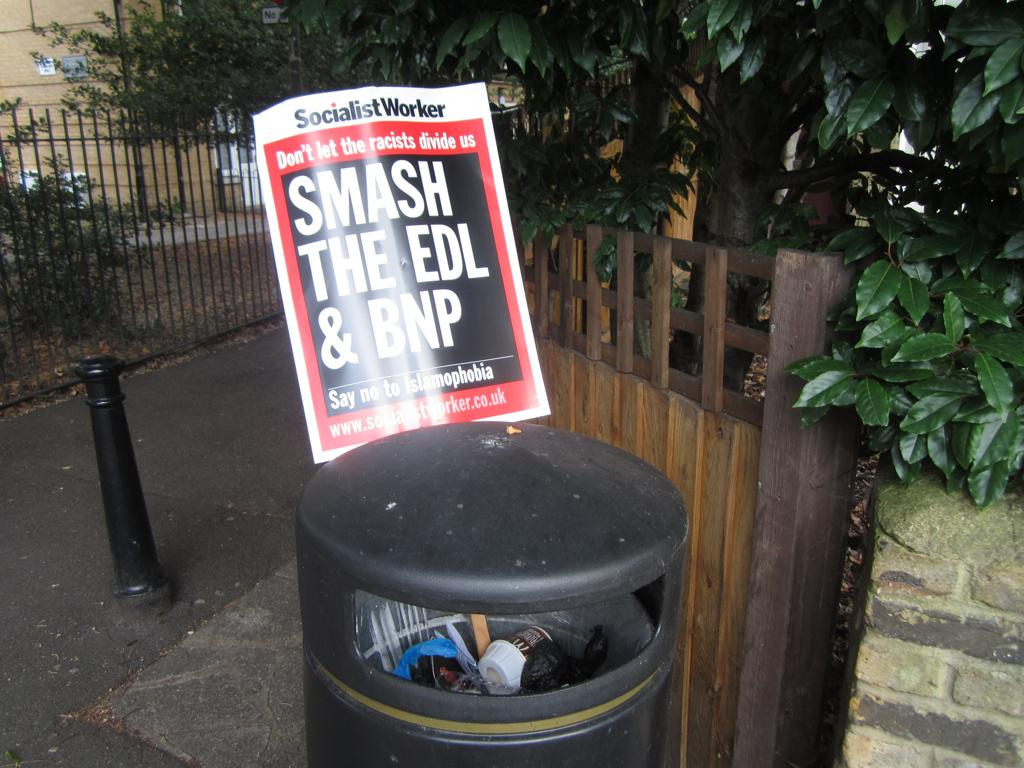<image>
Render a clear and concise summary of the photo. White and black sign which says Smash the EDL & BNP. 